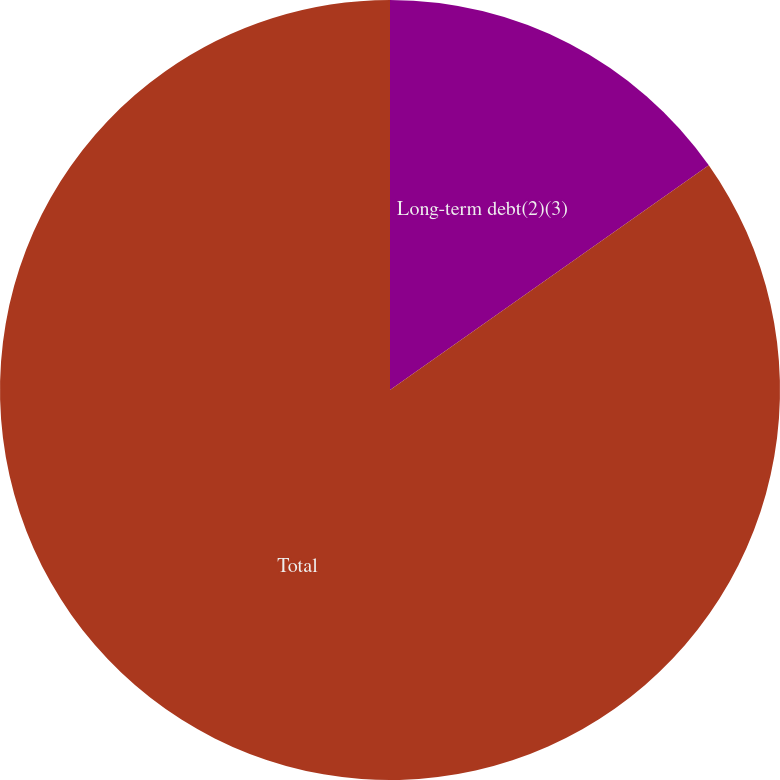Convert chart. <chart><loc_0><loc_0><loc_500><loc_500><pie_chart><fcel>Long-term debt(2)(3)<fcel>Total<nl><fcel>15.23%<fcel>84.77%<nl></chart> 